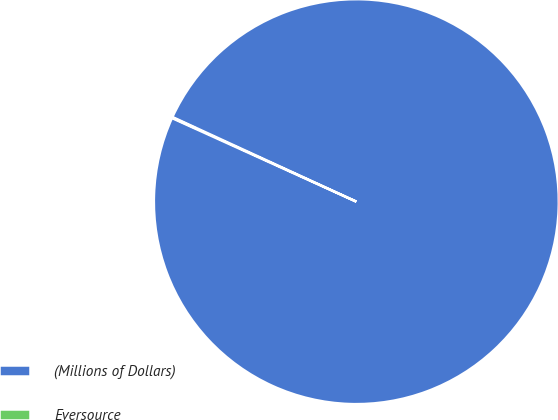Convert chart. <chart><loc_0><loc_0><loc_500><loc_500><pie_chart><fcel>(Millions of Dollars)<fcel>Eversource<nl><fcel>99.91%<fcel>0.09%<nl></chart> 